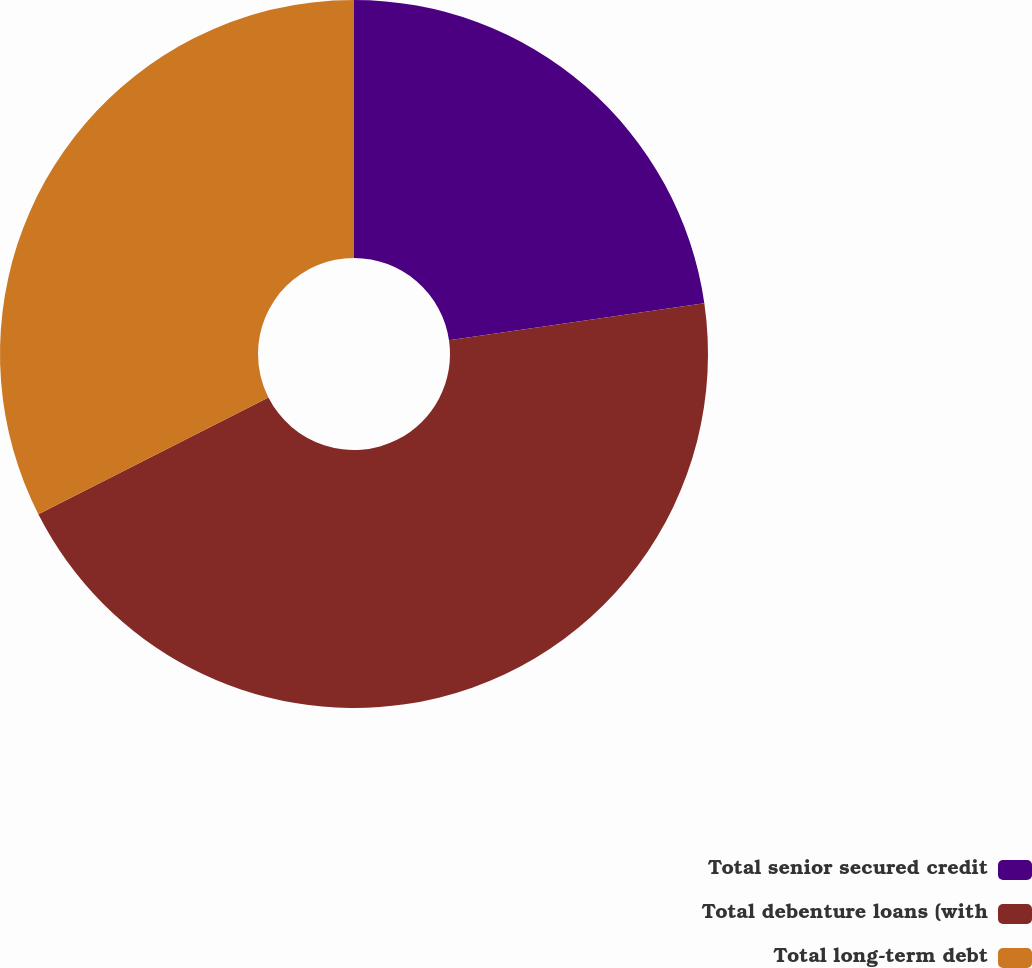<chart> <loc_0><loc_0><loc_500><loc_500><pie_chart><fcel>Total senior secured credit<fcel>Total debenture loans (with<fcel>Total long-term debt<nl><fcel>22.71%<fcel>44.82%<fcel>32.48%<nl></chart> 